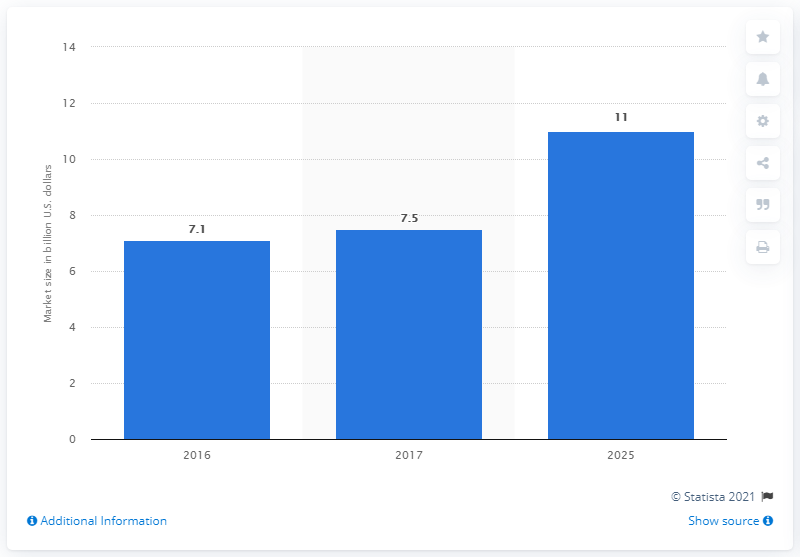List a handful of essential elements in this visual. The forecast for the global cancer imaging systems market in 2025 is [insert forecast information here]. The estimated market size for cancer imaging systems by 2025 is expected to be approximately 11... In 2016, the value of the global cancer imaging systems market was 7.1. 